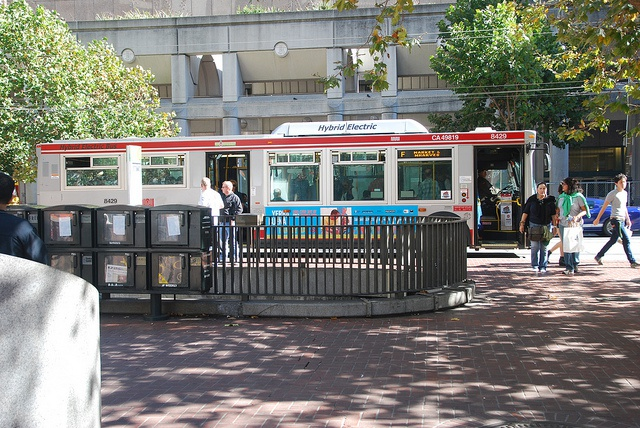Describe the objects in this image and their specific colors. I can see bus in white, lightgray, black, darkgray, and gray tones, people in white, darkgray, gray, and black tones, people in white, black, gray, and brown tones, people in white, black, navy, and gray tones, and people in white, black, darkgray, and navy tones in this image. 